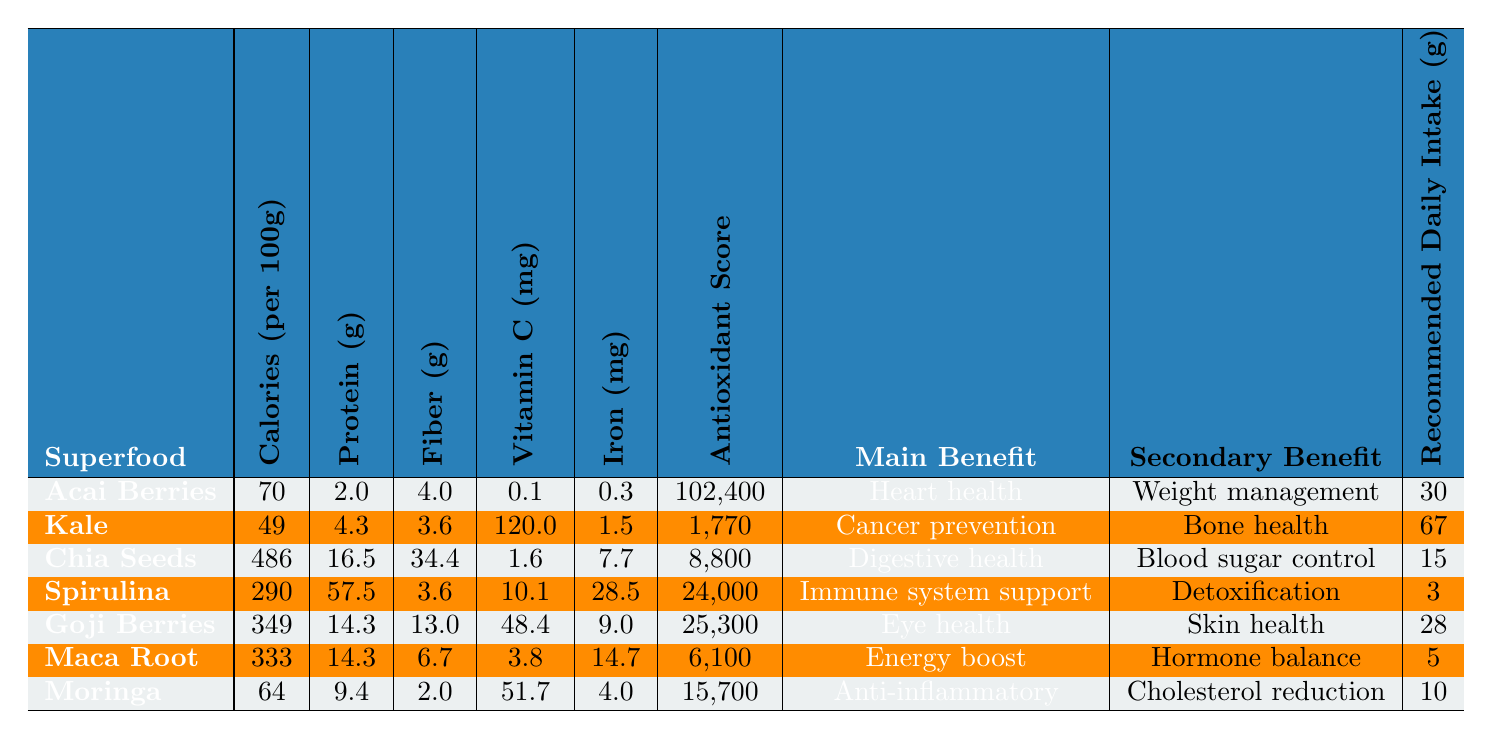What is the main health benefit of Spirulina? According to the table, the main benefit of Spirulina is "Immune system support."
Answer: Immune system support Which superfood has the highest antioxidant score? By examining the antioxidant scores listed, Spirulina has an antioxidant score of 24,000, which is the highest compared to the others.
Answer: Spirulina How many grams of protein are in Kale per 100g? The table states that Kale contains 4.3 grams of protein per 100 grams.
Answer: 4.3 What is the total recommended daily intake (g) of Acai Berries and Goji Berries? The recommended daily intake for Acai Berries is 30g and for Goji Berries is 28g. Adding these gives 30 + 28 = 58g.
Answer: 58 Is Kale popular in alternative medicine? The table indicates that Kale is marked as true for popularity in alternative medicine.
Answer: Yes Which superfood has the lowest calories per 100g? By comparing the calories per 100g for each superfood, Kale has the lowest calorie content at 49 calories.
Answer: Kale What is the main benefit of Moringa? According to the table, the main benefit of Moringa is "Anti-inflammatory."
Answer: Anti-inflammatory If you consume the recommended daily intake of Chia Seeds, how much fiber would you get? The table states that Chia Seeds contain 34.4g of fiber per 100g and the recommended daily intake is 15g. The fiber intake would be 15g/100g * 34.4g = 5.16g of fiber.
Answer: 5.16g Which superfood offers skin health as a secondary benefit? The table shows that Goji Berries list "Skin health" as the secondary benefit.
Answer: Goji Berries What is the average amount of iron per 100g for all the superfoods listed? The iron amounts for each superfood are: Acai Berries (0.3g), Kale (1.5g), Chia Seeds (7.7g), Spirulina (28.5g), Goji Berries (9g), Maca Root (14.7g), and Moringa (4g). Adding these gives a total of 71.7g. There are 7 superfoods, so the average is 71.7g / 7 = 10.24g.
Answer: 10.24g How does the fiber content in Chia Seeds compare to Moringa? Chia Seeds contain 34.4g of fiber while Moringa contains 2.0g, which shows that Chia Seeds have significantly more fiber than Moringa.
Answer: Chia Seeds have more fiber 